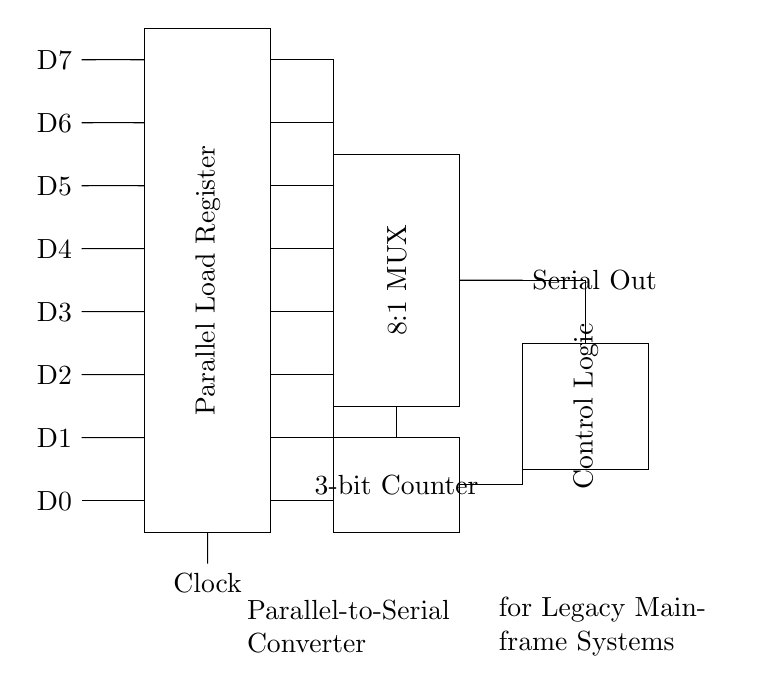What is the function of the 8:1 MUX? The 8:1 multiplexer allows the selection of one of the eight data inputs (D0 to D7) based on the control signals from the counter, converting parallel data input to a single serial output.
Answer: Selection of data How many bits are processed simultaneously? The circuit handles 8 bits at once, as indicated by the eight data inputs (D0 to D7).
Answer: Eight bits What is the role of the 3-bit counter? The 3-bit counter generates the necessary control signals to select which of the 8 data bits will be output serially, effectively controlling the timing of this conversion.
Answer: Control timing What is the output from the circuit labeled as? The output is labeled as 'Serial Out', indicating the format of data being transmitted after conversion.
Answer: Serial Out What component is responsible for holding the parallel data? The Parallel Load Register holds the incoming parallel data before it gets converted to serial by the multiplexer.
Answer: Parallel Load Register How is the clock signal used in the circuit? The clock signal synchronizes the operation of the parallel load register and the multiplexer, ensuring data is transferred at specific intervals for accurate serial transmission.
Answer: Synchronizes operation 